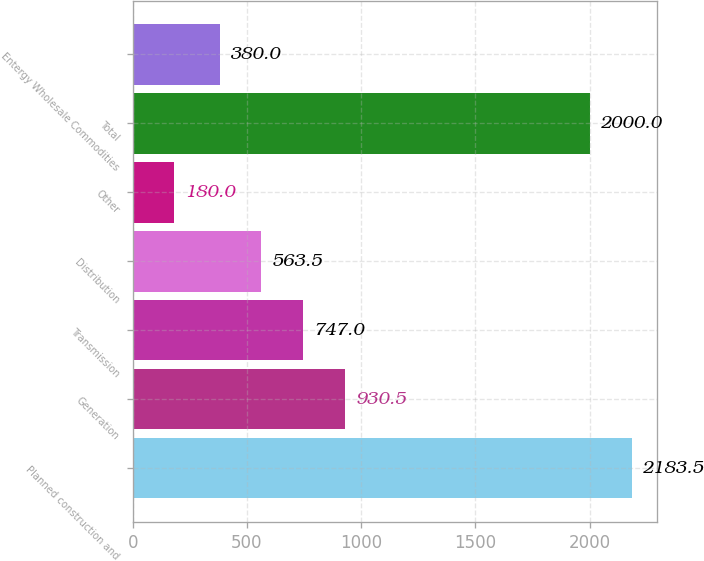<chart> <loc_0><loc_0><loc_500><loc_500><bar_chart><fcel>Planned construction and<fcel>Generation<fcel>Transmission<fcel>Distribution<fcel>Other<fcel>Total<fcel>Entergy Wholesale Commodities<nl><fcel>2183.5<fcel>930.5<fcel>747<fcel>563.5<fcel>180<fcel>2000<fcel>380<nl></chart> 